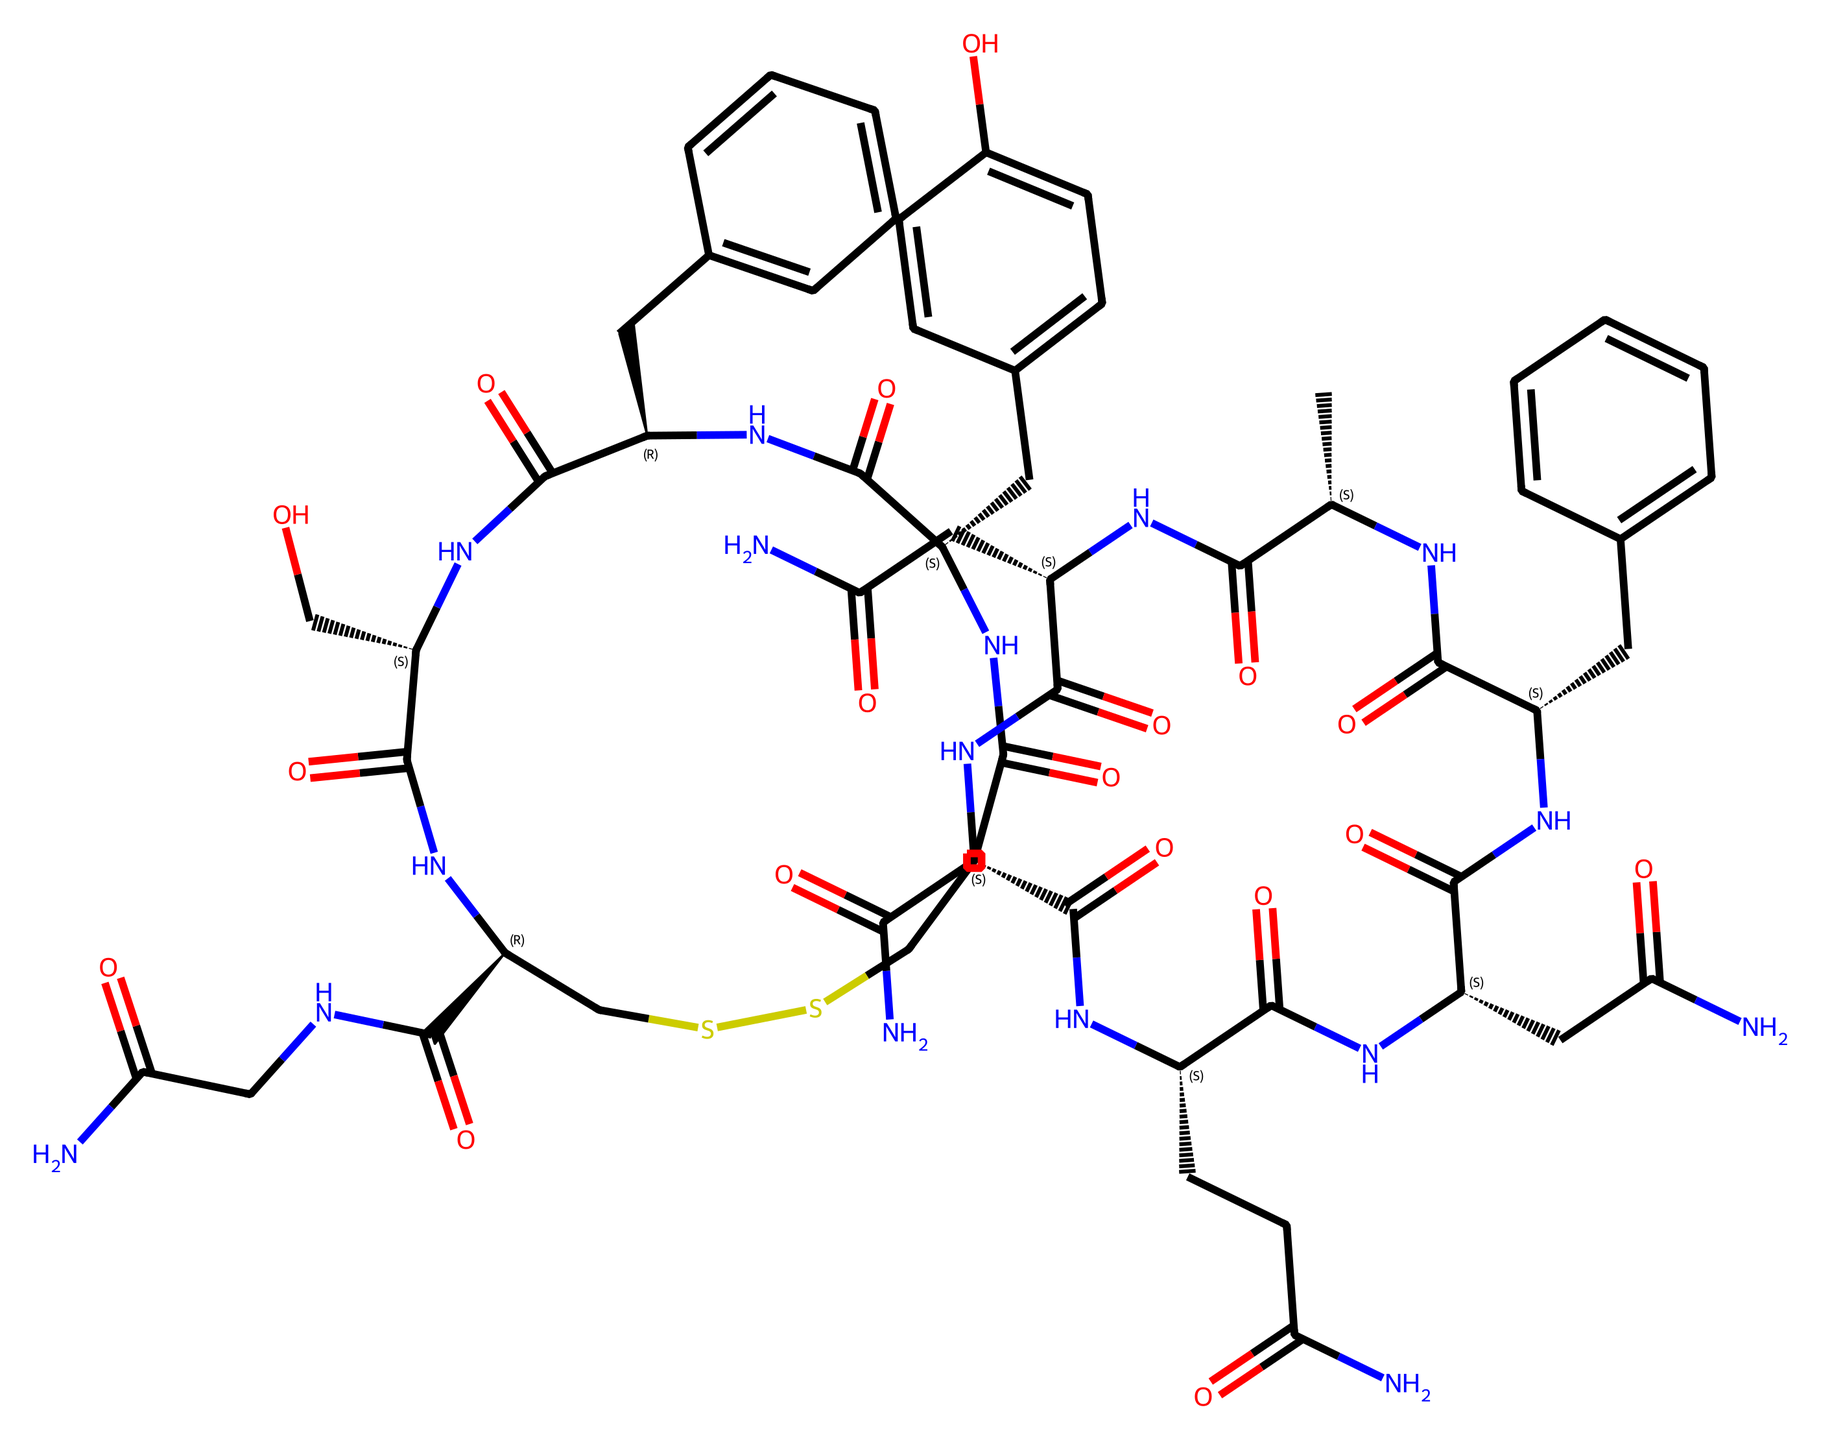What is the molecular formula of oxytocin? To find the molecular formula, we count the number of each type of atom present in the SMILES representation. The SMILES contains carbon (C), hydrogen (H), nitrogen (N), oxygen (O), and sulfur (S). Counting these gives a total of 43 carbons, 66 hydrogens, 12 nitrogens, 8 oxygens, and 1 sulfur. Thus, the molecular formula is C43H66N12O8S.
Answer: C43H66N12O8S How many nitrogen atoms are present in oxytocin? The number of nitrogen atoms can be directly observed in the SMILES where 'N' represents nitrogen. By scanning through the SMILES string, we find that there are a total of 12 nitrogen atoms.
Answer: 12 What is the primary function of oxytocin in the human body? The primary function of oxytocin can be derived from its common name, "bonding hormone." It regulates social bonding, sexual reproduction, and childbirth. It is involved in emotional responses and nurturing behavior.
Answer: bonding hormone Which atom in oxytocin is involved in disulfide bonding? Disulfide bonds are formed between sulfur atoms. In the SMILES representation, 'S' indicates sulfur. Upon examining the structure, there are two sulfur atoms suggesting that they can form a disulfide bond.
Answer: sulfur What type of biomolecule is oxytocin classified as? Oxytocin is a peptide, which is a chain of amino acids. The presence of multiple nitrogen atoms and carbon skeleton indicates it is formed of amino acids linked together, fitting the classification of a peptide hormone.
Answer: peptide How many rings are present in the oxytocin structure? To find the number of rings, we look for cyclic structures in the SMILES. The term 'C' or 'C@' signifies carbon atoms involved in a ring structure. The visualization of the molecule reveals that there are two ring structures.
Answer: 2 